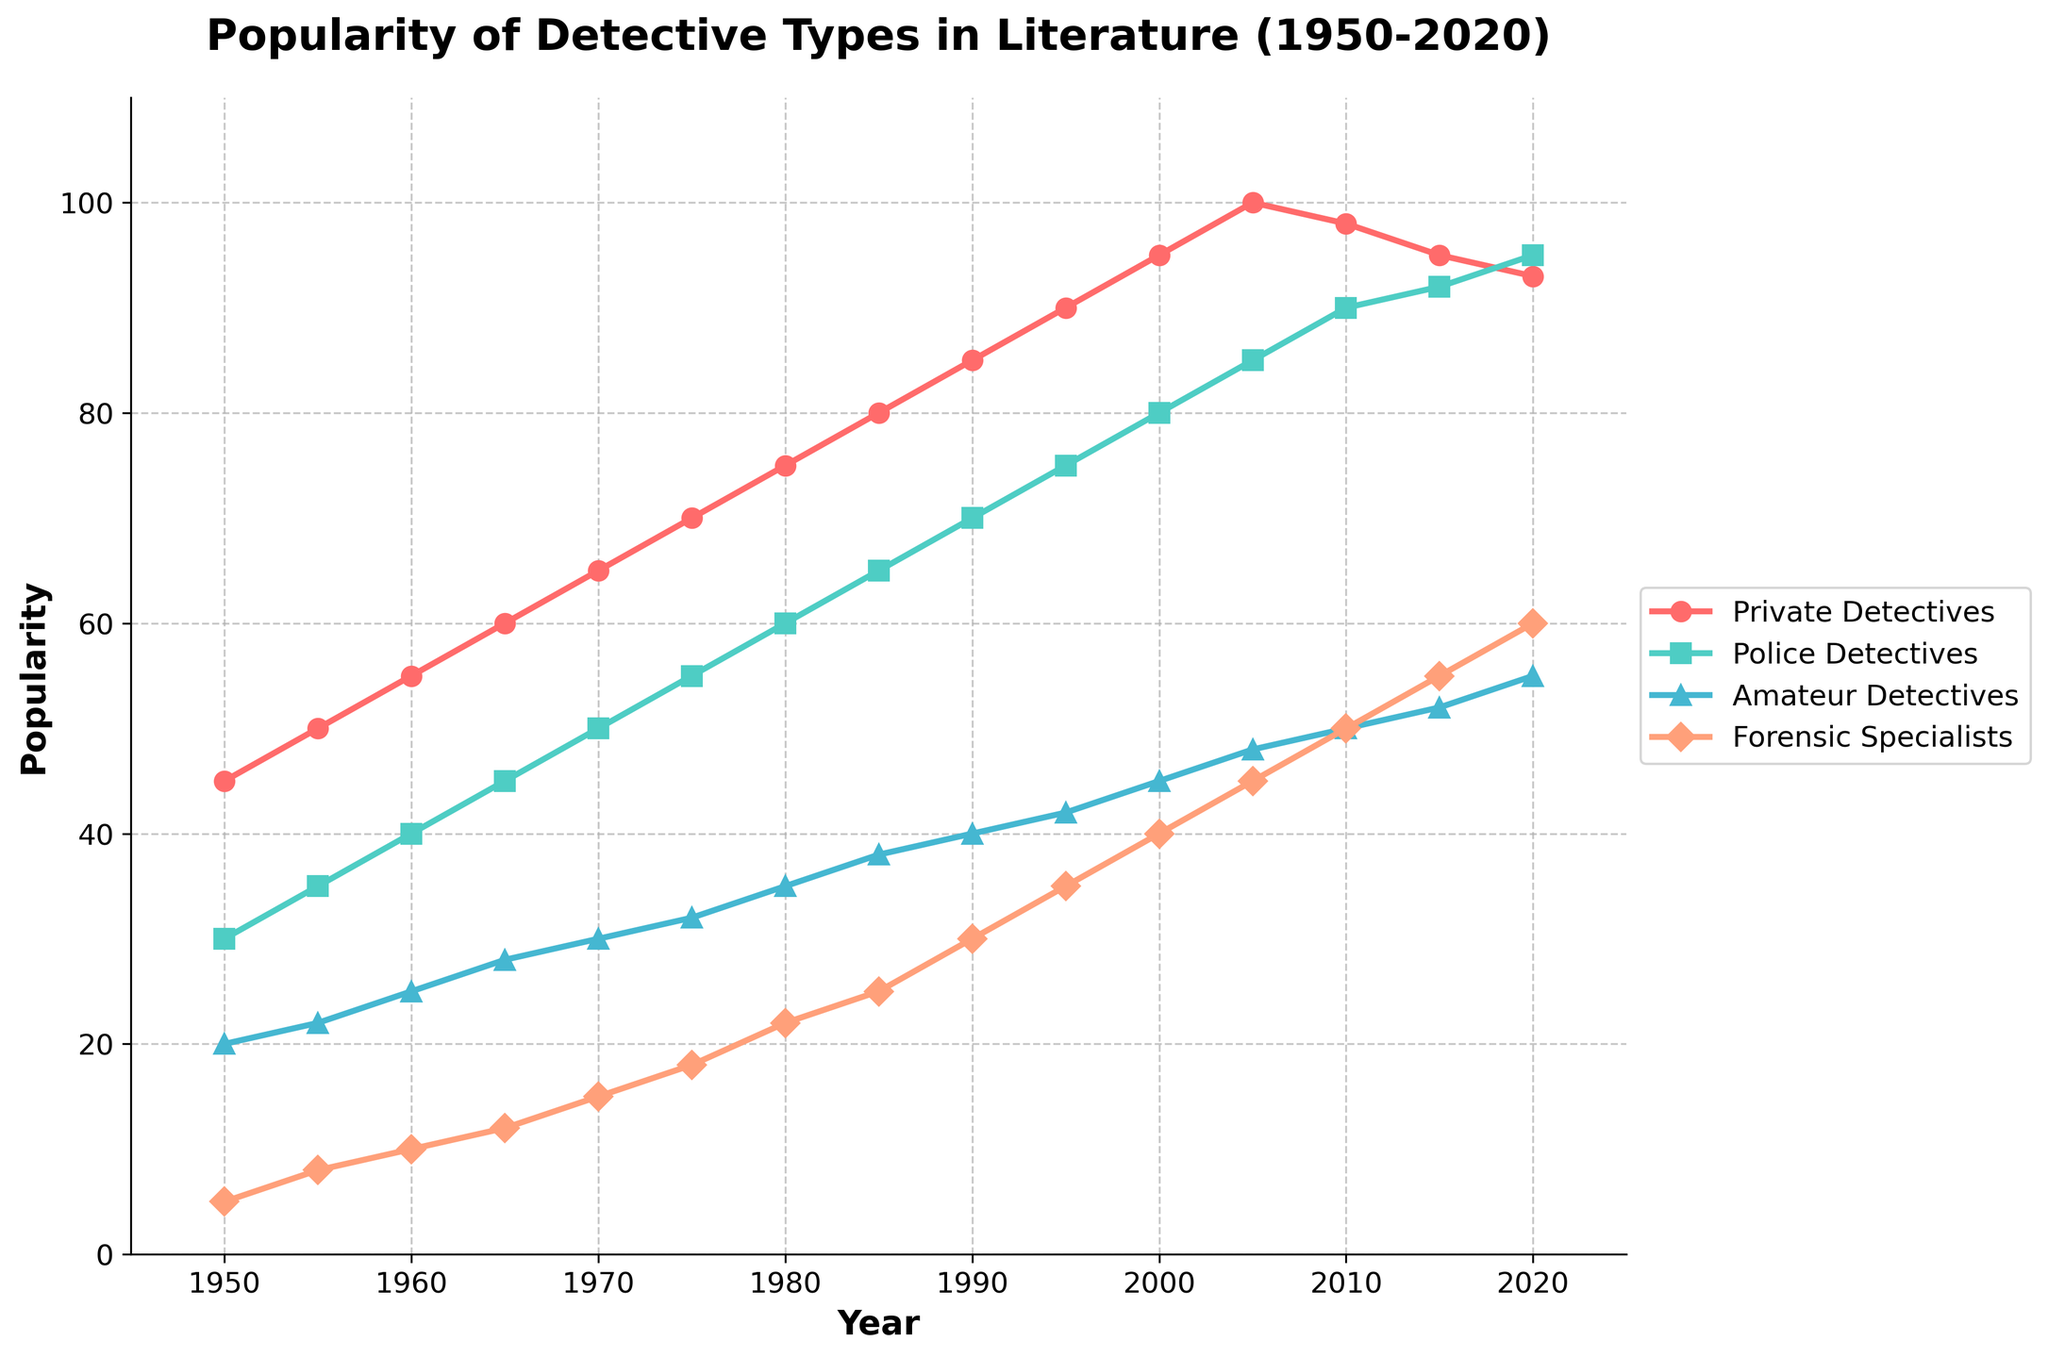What's the trend in popularity for private detectives from 1950 to 2020? Observe the line for private detectives, which shows a general increasing trend from 1950 (45) to 2005 (100), followed by a slight decrease to 2020 (93).
Answer: Increasing until 2005, then slight decrease Which detective type had the highest popularity in 2020? Look at the endpoints of each line in 2020. Police Detectives reach 95, which is higher than the other lines.
Answer: Police Detectives How does the popularity of amateur detectives in 1960 compare to that of forensic specialists in 1995? Locate 1960 on the x-axis for amateur detectives (25), then locate 1995 for forensic specialists (35). Compare the two values.
Answer: Forensic Specialists in 1995 are more popular Between which years did forensic specialists see the highest growth in popularity? Identify the steepest slope in the line for forensic specialists. The largest growth occurs between 2000 (40) and 2020 (60).
Answer: 2000 to 2020 How much more popular were private detectives compared to amateur detectives in 2000? In 2000, private detectives have 95, and amateur detectives have 45. Calculate the difference: 95 - 45 = 50.
Answer: 50 In which decade did police detectives surpass 65 in popularity? Trace the line for police detectives to see when it reaches past 65. This happens between 1985 (65) and 1990 (70).
Answer: 1980s Which detective type had the least fluctuation in popularity over the entire period? Compare the range (difference between the highest and lowest points) of all lines. Amateur detectives range from 20 (1950) to 55 (2020), which has a 35-point increase. This is the most steady compared to others.
Answer: Amateur Detectives What is the average popularity of forensic specialists between 1950 and 2020? Sum all the values for forensic specialists (5+8+10+12+15+18+22+25+30+35+40+45+50+55+60 = 400) and divide by the number of data points (15): 400/15 ≈ 26.67.
Answer: About 26.67 In 2010, how did the popularity of private detectives compare to the sum of police detectives and forensic specialists? Private detectives in 2010 are at 98. The sum of police detectives (90) and forensic specialists (50) is 140 (90+50 = 140).
Answer: Private detectives are less popular What was the popularity increase for police detectives from 1950 to 2020? Police detectives in 1950 are at 30, and in 2020 are at 95. Calculate the increase: 95 - 30 = 65.
Answer: 65 